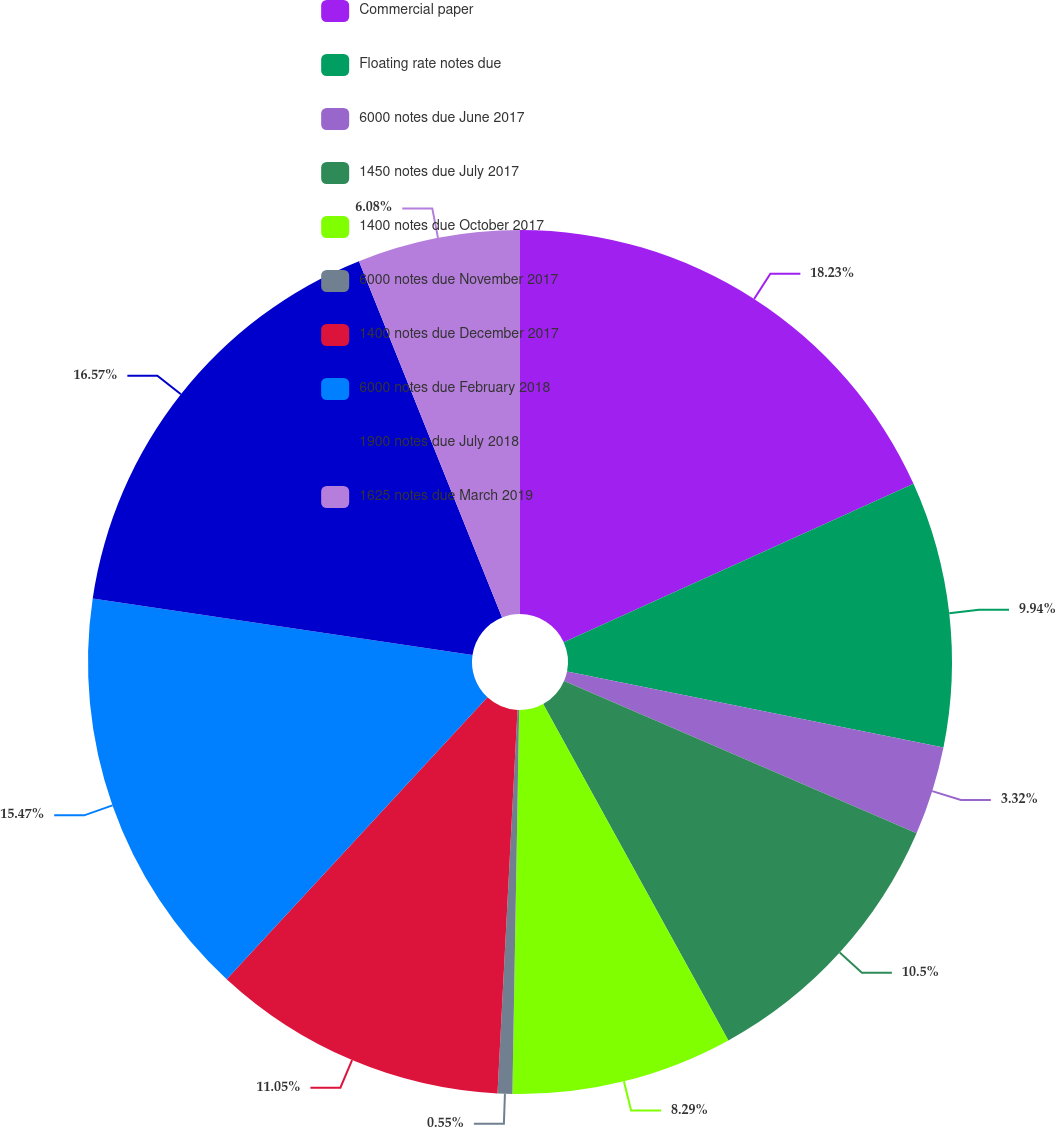<chart> <loc_0><loc_0><loc_500><loc_500><pie_chart><fcel>Commercial paper<fcel>Floating rate notes due<fcel>6000 notes due June 2017<fcel>1450 notes due July 2017<fcel>1400 notes due October 2017<fcel>6000 notes due November 2017<fcel>1400 notes due December 2017<fcel>6000 notes due February 2018<fcel>1900 notes due July 2018<fcel>1625 notes due March 2019<nl><fcel>18.23%<fcel>9.94%<fcel>3.32%<fcel>10.5%<fcel>8.29%<fcel>0.55%<fcel>11.05%<fcel>15.47%<fcel>16.57%<fcel>6.08%<nl></chart> 